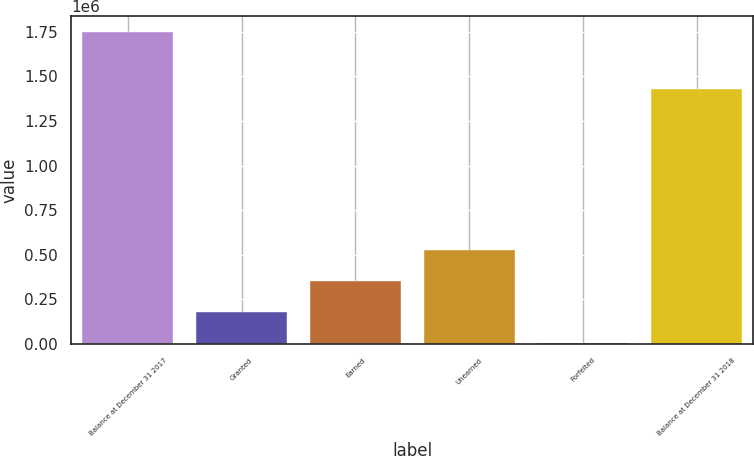Convert chart. <chart><loc_0><loc_0><loc_500><loc_500><bar_chart><fcel>Balance at December 31 2017<fcel>Granted<fcel>Earned<fcel>Unearned<fcel>Forfeited<fcel>Balance at December 31 2018<nl><fcel>1.74875e+06<fcel>177638<fcel>352206<fcel>526775<fcel>3070<fcel>1.42683e+06<nl></chart> 